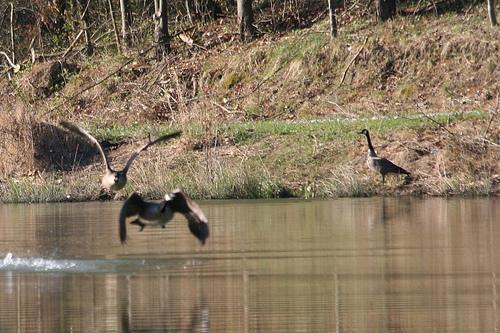How many geese are there?
Give a very brief answer. 3. How many cranes?
Give a very brief answer. 3. 